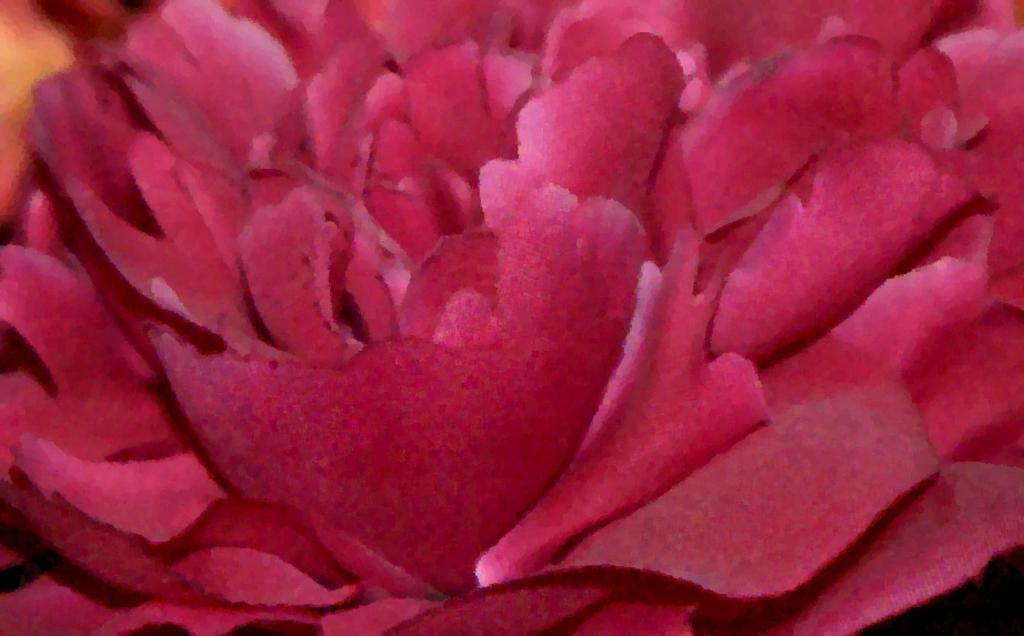Could you give a brief overview of what you see in this image? In this image I can see a rose color flower. 